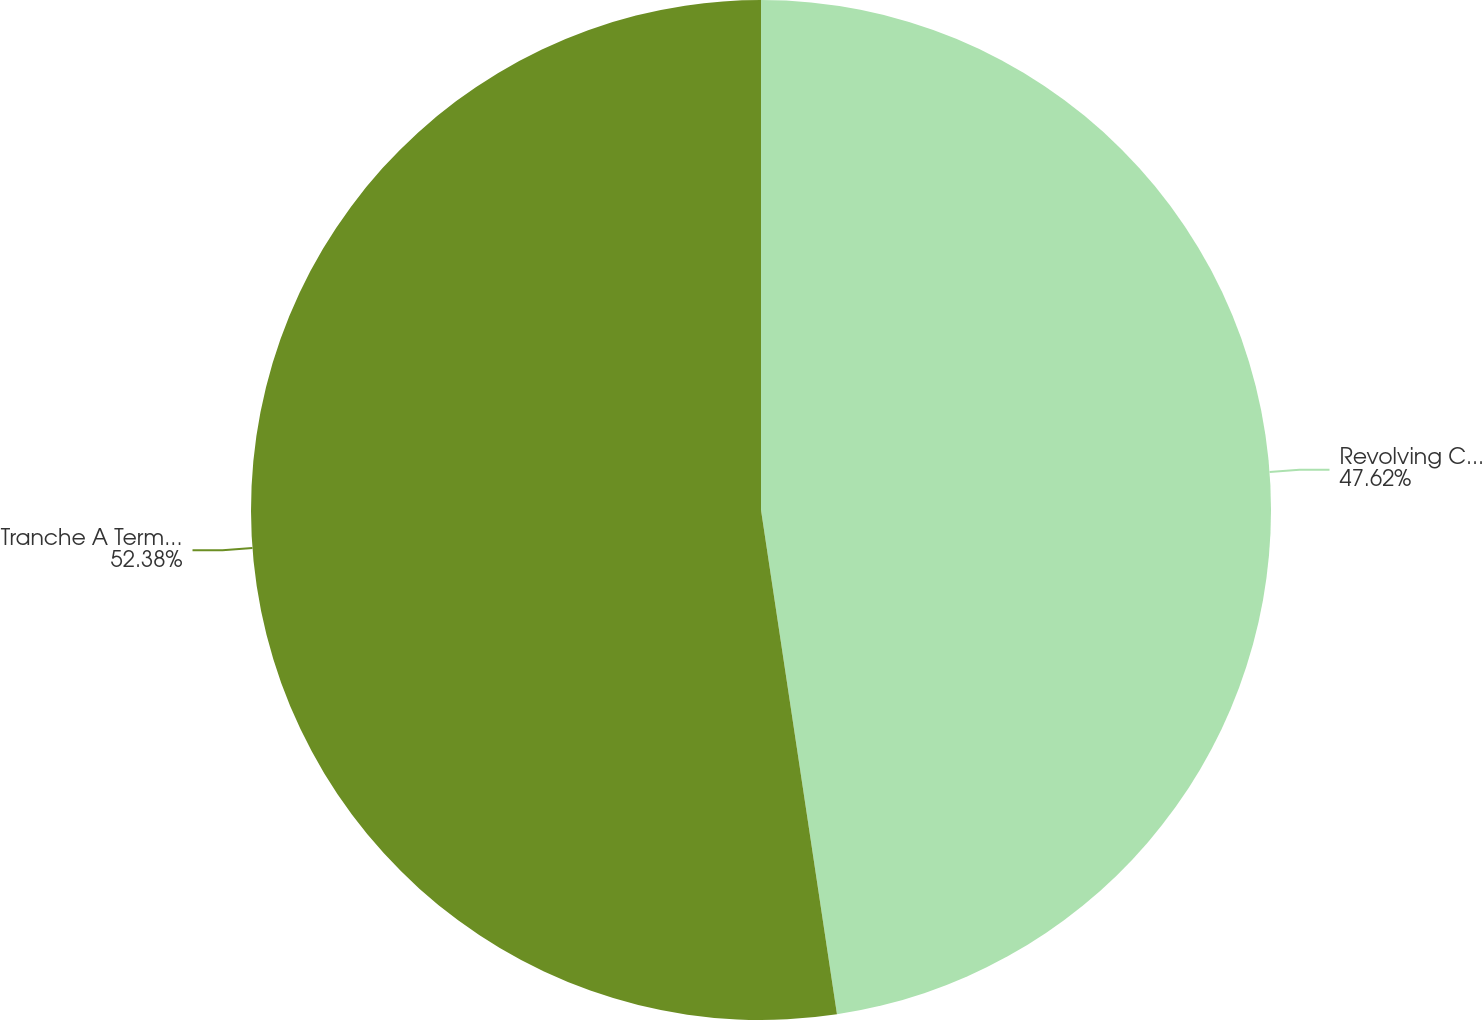<chart> <loc_0><loc_0><loc_500><loc_500><pie_chart><fcel>Revolving Credit Facility<fcel>Tranche A Term Loan<nl><fcel>47.62%<fcel>52.38%<nl></chart> 